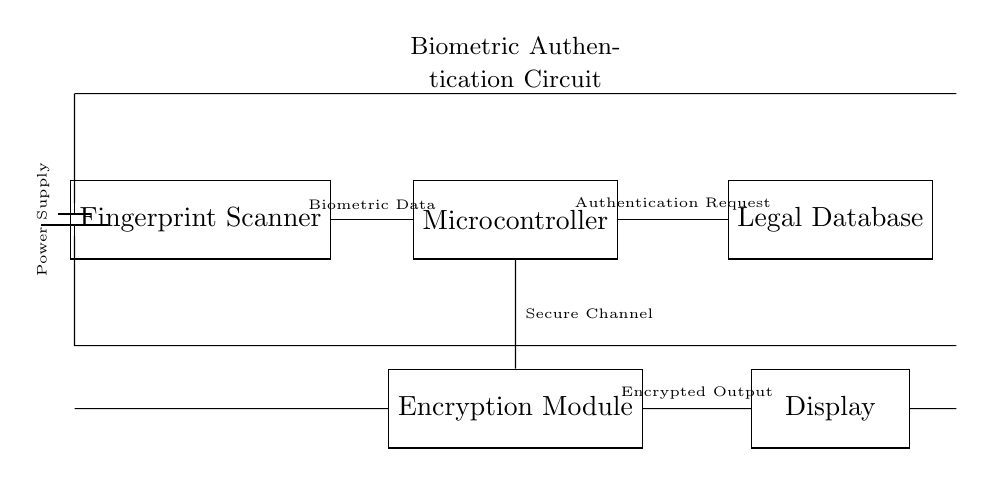What is the first component in the circuit? The first component is the Fingerprint Scanner, which is positioned at the leftmost part of the diagram. It is depicted as a rectangle labeled as such, indicating its role in biometric data collection.
Answer: Fingerprint Scanner What type of circuit is represented here? This circuit is a biometric authentication circuit, as it is specifically designed for processing biometric data to authenticate access to sensitive information. The components indicate functionality related to biometric authentication, encryption, and data retrieval.
Answer: Biometric authentication What does the microcontroller connect to? The microcontroller connects to three components: the Fingerprint Scanner (for biometric data), the Legal Database (for authentication requests), and the Encryption Module (for secure communication). Notably, this indicates its central role in processing data and directing information flow.
Answer: Fingerprint Scanner, Legal Database, Encryption Module How is the data from the Fingerprint Scanner transmitted? The data from the Fingerprint Scanner is transmitted to the microcontroller as Biometric Data, as indicated by the labeled connection line. This shows that the biometric information is initially processed by the microcontroller.
Answer: Biometric Data What is the purpose of the Encryption Module? The purpose of the Encryption Module is to provide a Secure Channel for data transmission, ensuring that the information exchanged between the microcontroller and other components, like the display, is encrypted for security, which is crucial for accessing sensitive client information.
Answer: Secure Channel 